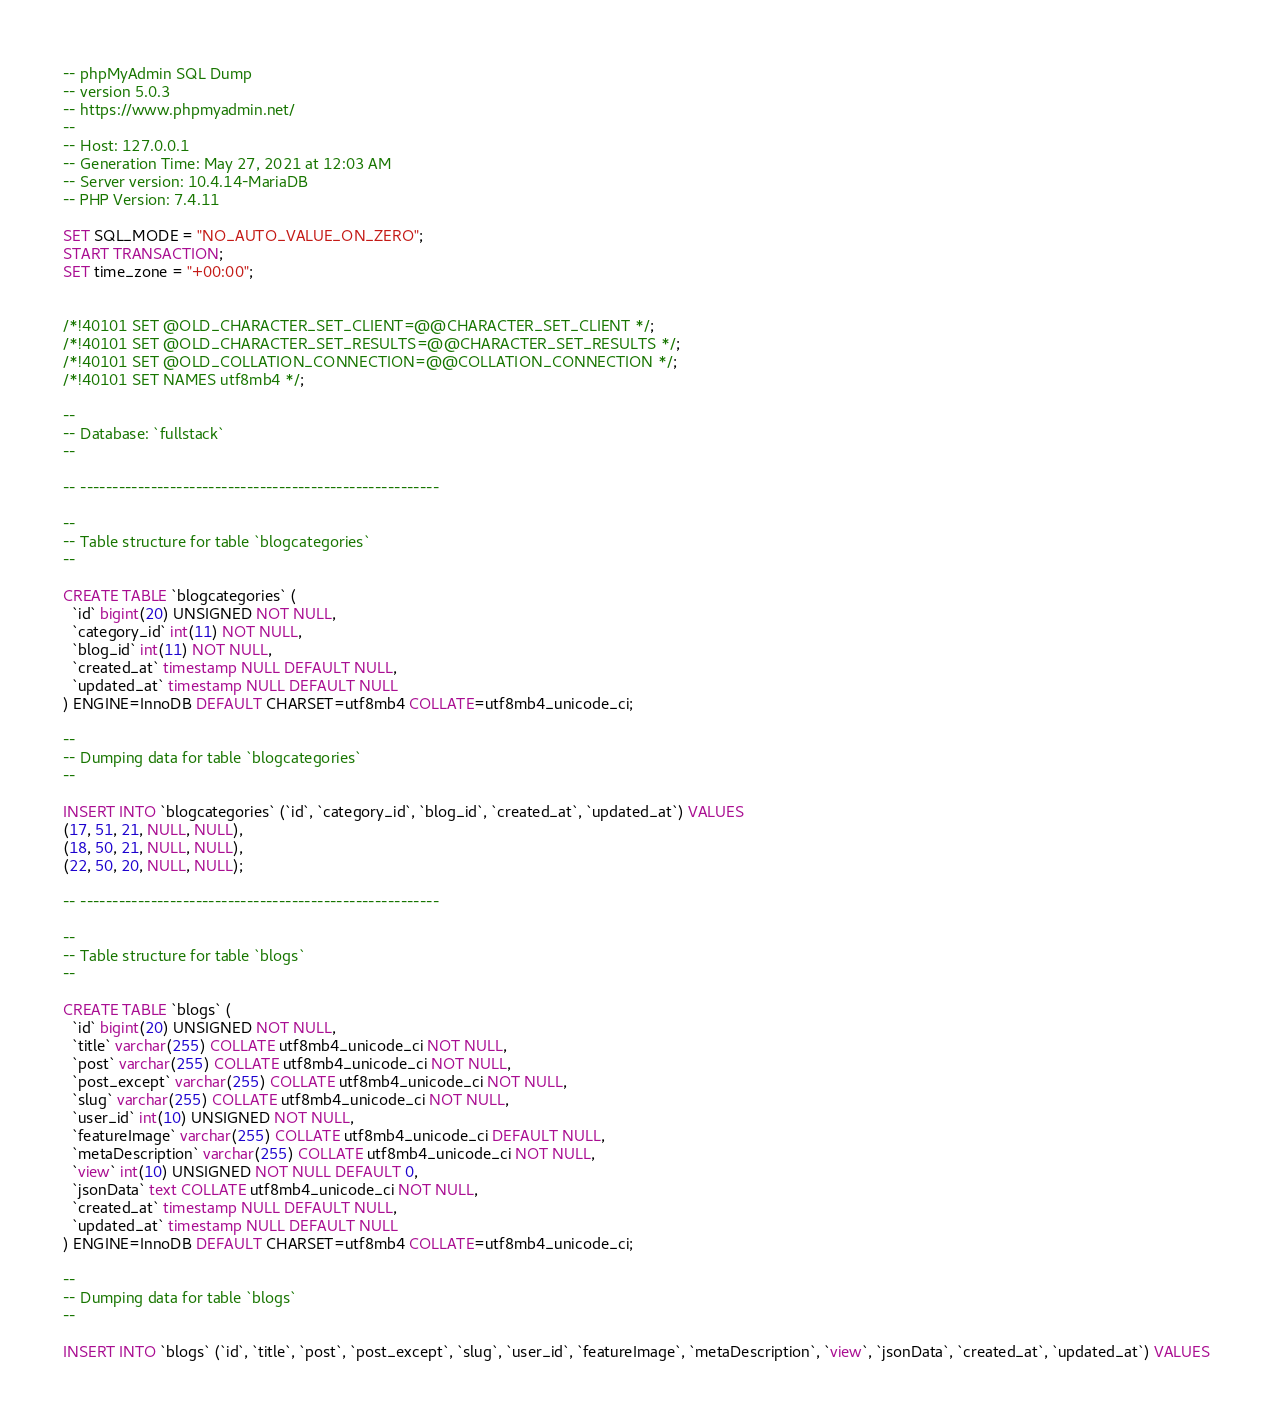Convert code to text. <code><loc_0><loc_0><loc_500><loc_500><_SQL_>-- phpMyAdmin SQL Dump
-- version 5.0.3
-- https://www.phpmyadmin.net/
--
-- Host: 127.0.0.1
-- Generation Time: May 27, 2021 at 12:03 AM
-- Server version: 10.4.14-MariaDB
-- PHP Version: 7.4.11

SET SQL_MODE = "NO_AUTO_VALUE_ON_ZERO";
START TRANSACTION;
SET time_zone = "+00:00";


/*!40101 SET @OLD_CHARACTER_SET_CLIENT=@@CHARACTER_SET_CLIENT */;
/*!40101 SET @OLD_CHARACTER_SET_RESULTS=@@CHARACTER_SET_RESULTS */;
/*!40101 SET @OLD_COLLATION_CONNECTION=@@COLLATION_CONNECTION */;
/*!40101 SET NAMES utf8mb4 */;

--
-- Database: `fullstack`
--

-- --------------------------------------------------------

--
-- Table structure for table `blogcategories`
--

CREATE TABLE `blogcategories` (
  `id` bigint(20) UNSIGNED NOT NULL,
  `category_id` int(11) NOT NULL,
  `blog_id` int(11) NOT NULL,
  `created_at` timestamp NULL DEFAULT NULL,
  `updated_at` timestamp NULL DEFAULT NULL
) ENGINE=InnoDB DEFAULT CHARSET=utf8mb4 COLLATE=utf8mb4_unicode_ci;

--
-- Dumping data for table `blogcategories`
--

INSERT INTO `blogcategories` (`id`, `category_id`, `blog_id`, `created_at`, `updated_at`) VALUES
(17, 51, 21, NULL, NULL),
(18, 50, 21, NULL, NULL),
(22, 50, 20, NULL, NULL);

-- --------------------------------------------------------

--
-- Table structure for table `blogs`
--

CREATE TABLE `blogs` (
  `id` bigint(20) UNSIGNED NOT NULL,
  `title` varchar(255) COLLATE utf8mb4_unicode_ci NOT NULL,
  `post` varchar(255) COLLATE utf8mb4_unicode_ci NOT NULL,
  `post_except` varchar(255) COLLATE utf8mb4_unicode_ci NOT NULL,
  `slug` varchar(255) COLLATE utf8mb4_unicode_ci NOT NULL,
  `user_id` int(10) UNSIGNED NOT NULL,
  `featureImage` varchar(255) COLLATE utf8mb4_unicode_ci DEFAULT NULL,
  `metaDescription` varchar(255) COLLATE utf8mb4_unicode_ci NOT NULL,
  `view` int(10) UNSIGNED NOT NULL DEFAULT 0,
  `jsonData` text COLLATE utf8mb4_unicode_ci NOT NULL,
  `created_at` timestamp NULL DEFAULT NULL,
  `updated_at` timestamp NULL DEFAULT NULL
) ENGINE=InnoDB DEFAULT CHARSET=utf8mb4 COLLATE=utf8mb4_unicode_ci;

--
-- Dumping data for table `blogs`
--

INSERT INTO `blogs` (`id`, `title`, `post`, `post_except`, `slug`, `user_id`, `featureImage`, `metaDescription`, `view`, `jsonData`, `created_at`, `updated_at`) VALUES</code> 